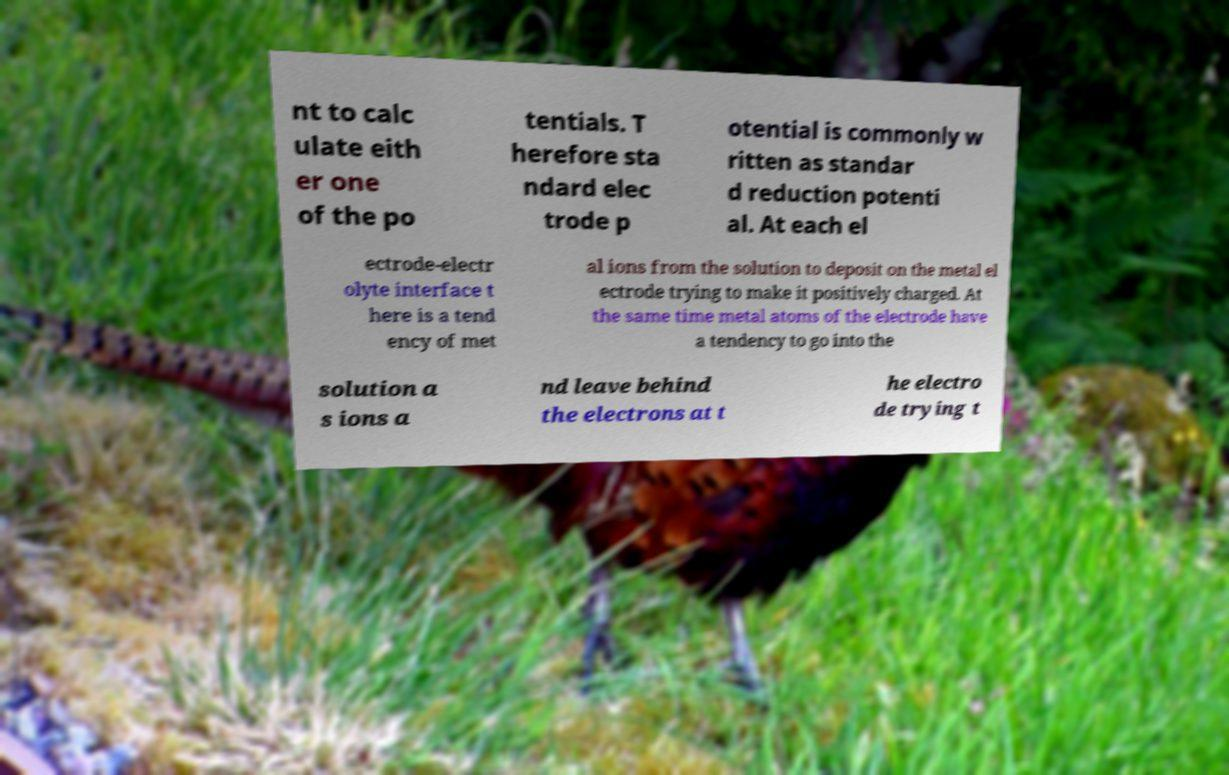Please read and relay the text visible in this image. What does it say? nt to calc ulate eith er one of the po tentials. T herefore sta ndard elec trode p otential is commonly w ritten as standar d reduction potenti al. At each el ectrode-electr olyte interface t here is a tend ency of met al ions from the solution to deposit on the metal el ectrode trying to make it positively charged. At the same time metal atoms of the electrode have a tendency to go into the solution a s ions a nd leave behind the electrons at t he electro de trying t 